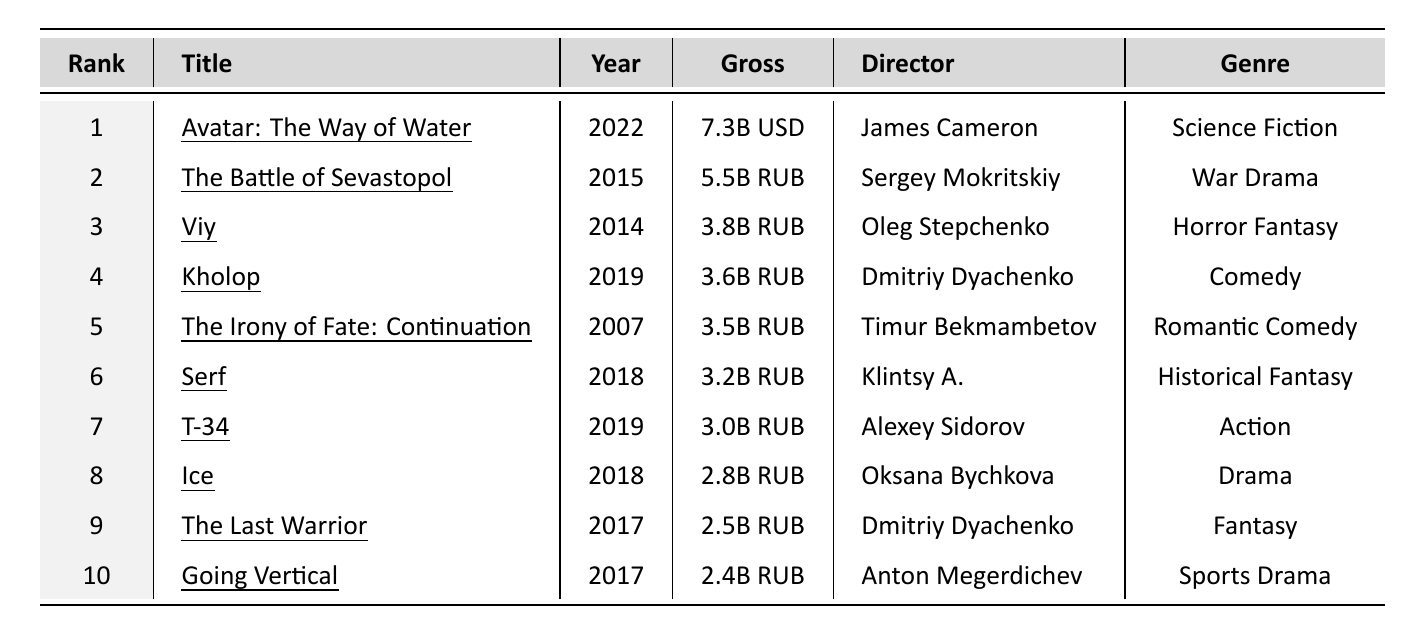What is the highest-grossing Russian film? The table shows that the highest-grossing Russian film is "The Battle of Sevastopol" which grossed 5.5 billion RUB.
Answer: "The Battle of Sevastopol" How much did "Kholop" gross? The table indicates that "Kholop" grossed 3.6 billion RUB.
Answer: 3.6 billion RUB Which film was directed by Oleg Stepchenko? From the table, "Viy" was directed by Oleg Stepchenko.
Answer: "Viy" Are there any films that grossed over 4 billion RUB? The only film listed that grossed over 4 billion RUB is "The Battle of Sevastopol" which grossed 5.5 billion RUB.
Answer: Yes What is the total gross of the top three Russian films? Adding the gross of the top three films: 5.5 billion RUB + 3.8 billion RUB + 3.6 billion RUB = 13.0 billion RUB.
Answer: 13.0 billion RUB Which director has multiple films in the top 10? The table shows that Dmitriy Dyachenko directed both "Kholop" and "The Last Warrior," illustrating he has multiple films in the top 10.
Answer: Dmitriy Dyachenko What is the average gross of the top 10 Russian films? First, we sum the grosses: 5.5 + 3.8 + 3.6 + 3.5 + 3.2 + 3.0 + 2.8 + 2.5 + 2.4 = 28.3 billion RUB. There are 10 films, so the average is 28.3 / 10 = 2.83 billion RUB.
Answer: 2.83 billion RUB Which film released in 2019 had the highest gross? "Kholop" was released in 2019, grossing 3.6 billion RUB, which is higher than "T-34," released the same year at 3.0 billion RUB.
Answer: "Kholop" Is there a film in the top 10 that belongs to the Comedy genre? Yes, "Kholop" is a Comedy and is listed in the top 10.
Answer: Yes Which film has the lowest gross in the top 10? The film with the lowest gross in the top 10 is "Going Vertical," with a gross of 2.4 billion RUB.
Answer: "Going Vertical" What is the total gross of films from 2018? From the films released in 2018, we have "Serf" (3.2 billion RUB), "T-34" (3.0 billion RUB), and "Ice" (2.8 billion RUB). Adding these gives 3.2 + 3.0 + 2.8 = 9.0 billion RUB.
Answer: 9.0 billion RUB 